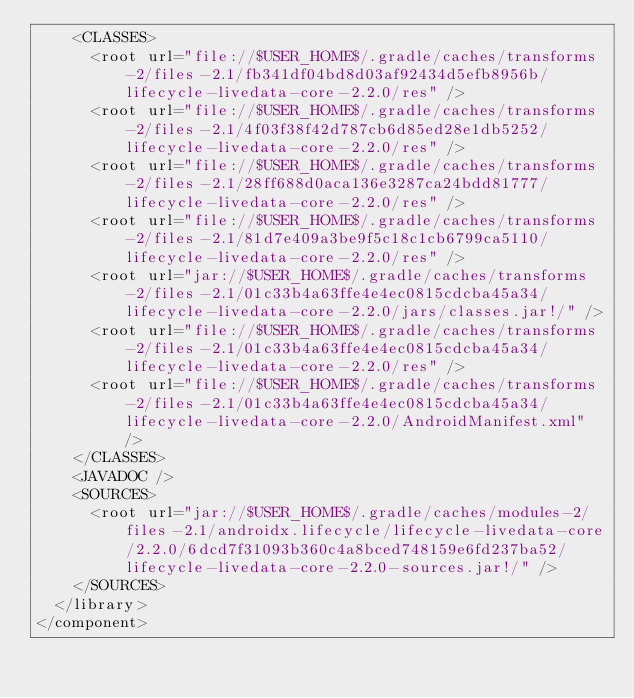<code> <loc_0><loc_0><loc_500><loc_500><_XML_>    <CLASSES>
      <root url="file://$USER_HOME$/.gradle/caches/transforms-2/files-2.1/fb341df04bd8d03af92434d5efb8956b/lifecycle-livedata-core-2.2.0/res" />
      <root url="file://$USER_HOME$/.gradle/caches/transforms-2/files-2.1/4f03f38f42d787cb6d85ed28e1db5252/lifecycle-livedata-core-2.2.0/res" />
      <root url="file://$USER_HOME$/.gradle/caches/transforms-2/files-2.1/28ff688d0aca136e3287ca24bdd81777/lifecycle-livedata-core-2.2.0/res" />
      <root url="file://$USER_HOME$/.gradle/caches/transforms-2/files-2.1/81d7e409a3be9f5c18c1cb6799ca5110/lifecycle-livedata-core-2.2.0/res" />
      <root url="jar://$USER_HOME$/.gradle/caches/transforms-2/files-2.1/01c33b4a63ffe4e4ec0815cdcba45a34/lifecycle-livedata-core-2.2.0/jars/classes.jar!/" />
      <root url="file://$USER_HOME$/.gradle/caches/transforms-2/files-2.1/01c33b4a63ffe4e4ec0815cdcba45a34/lifecycle-livedata-core-2.2.0/res" />
      <root url="file://$USER_HOME$/.gradle/caches/transforms-2/files-2.1/01c33b4a63ffe4e4ec0815cdcba45a34/lifecycle-livedata-core-2.2.0/AndroidManifest.xml" />
    </CLASSES>
    <JAVADOC />
    <SOURCES>
      <root url="jar://$USER_HOME$/.gradle/caches/modules-2/files-2.1/androidx.lifecycle/lifecycle-livedata-core/2.2.0/6dcd7f31093b360c4a8bced748159e6fd237ba52/lifecycle-livedata-core-2.2.0-sources.jar!/" />
    </SOURCES>
  </library>
</component></code> 